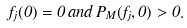Convert formula to latex. <formula><loc_0><loc_0><loc_500><loc_500>f _ { j } ( 0 ) = 0 \, a n d \, P _ { M } ( f _ { j } , 0 ) > 0 .</formula> 